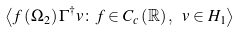<formula> <loc_0><loc_0><loc_500><loc_500>\left \langle f \left ( \Omega _ { 2 } \right ) \Gamma ^ { \dagger } v \colon f \in C _ { c } \left ( \mathbb { R } \right ) , \text { } v \in H _ { 1 } \right \rangle</formula> 